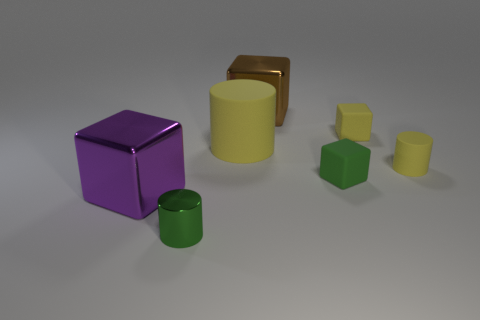There is another yellow object that is the same shape as the big yellow matte thing; what is its size?
Keep it short and to the point. Small. Are there any tiny green cubes made of the same material as the brown thing?
Provide a short and direct response. No. What is the large cube that is in front of the big brown cube made of?
Offer a very short reply. Metal. Does the large shiny thing that is in front of the tiny yellow cylinder have the same color as the shiny thing that is behind the small green rubber object?
Your answer should be very brief. No. The other cube that is the same size as the yellow matte block is what color?
Provide a succinct answer. Green. What number of other objects are there of the same shape as the large purple thing?
Offer a very short reply. 3. How big is the yellow cylinder on the right side of the brown metal object?
Provide a succinct answer. Small. There is a metallic cube that is behind the big purple metal cube; what number of large things are to the left of it?
Provide a short and direct response. 2. What number of other things are the same size as the green cylinder?
Ensure brevity in your answer.  3. Do the tiny shiny cylinder and the large matte object have the same color?
Keep it short and to the point. No. 